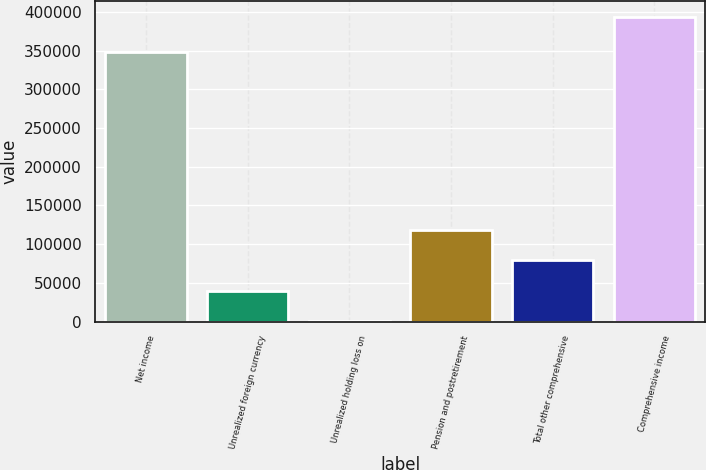Convert chart to OTSL. <chart><loc_0><loc_0><loc_500><loc_500><bar_chart><fcel>Net income<fcel>Unrealized foreign currency<fcel>Unrealized holding loss on<fcel>Pension and postretirement<fcel>Total other comprehensive<fcel>Comprehensive income<nl><fcel>348380<fcel>39537.5<fcel>147<fcel>118318<fcel>78928<fcel>394052<nl></chart> 